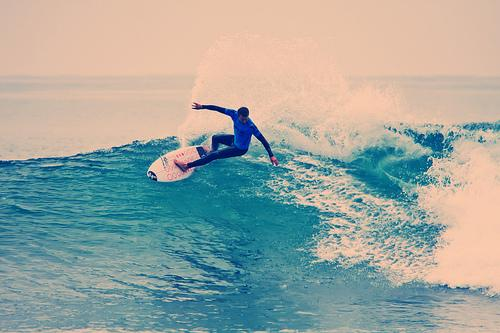Describe the overall atmosphere of the image based on the weather and water conditions. The atmosphere is exhilarating and dynamic, with cloudy grey skies over the ocean and a mixture of calm blue waters and white ocean foam, spray, and cresting waves. What could be inferred about the man's skill level in surfing based on the details provided in the image? The man seems to be skilled and confident in surfing, as he is riding a cresting wave and maintaining balance with his arms extended. Analyze the composition of the image, including the placement of objects, colors, and movement. The image composition includes the man on the surfboard as the central object, surrounded by various water conditions and weather elements. There is a balance between calm and dynamic elements, with the man's movement complemented by the colors of his clothing and the contrasting colors of the water and sky. What are the prominent colors of the man's clothing, and where do they appear? The prominent colors of the man's clothing are blue on his shirt, black on the pants and lettering of the shirt, and black and blue on his wetsuit. What is the main object in the image, and what are the most prominent features of its environment? The main object is a man on a surfboard. Features of the environment include white ocean foam, a cresting wave, calm blue waters, cloudy grey skies, and ocean spray. List all visible elements of the man's appearance that allow you to infer he is a surfer. Surfboard, wetsuit, extended arms for balancing, position on a wave, and the presence of ocean spray and white surf. Count the number of surfboard-related objects or details mentioned in the image. There are at least 7 surfboard-related objects or details: the surfboard itself, red lettering, white color, edge of the board, part of the board, pink rings, and the man on the surfboard. Describe any water-related objects or details surrounding the man in the image. There is white ocean foam in front of a wave, ocean spray coming off the back of the surfboard, a cresting wave rolling over, calm blue water behind the wave, white surf next to the man, and crystal blue water in front of him. Identify two different actions that the man on the surfboard is performing. The man is riding the surfboard and kicking up white spray with the surfboard. Mention two colors and their corresponding objects found in the image. Blue can be seen on the man's wetsuit, and red on the lettering on the white surfboard. Can you see any branding or logo on surfboard and man's shirt? Yes, there is red lettering on the surfboard and black lettering on the man's shirt Combine the following elements in a descriptive sentence: cloud, wetsuit, ocean, and lettering on the surfboard. As the man in the blue wetsuit gracefully glides amidst a cloudy ocean landscape, his white surfboard boasts vibrant red and black lettering that catches the eye. Choose the correct statement: The man is riding the wave toward the shore or The man is diving into the waves? The man is riding the wave toward the shore. What is the man's position in relation to the cresting wave? The man is in front of the cresting wave. Identify any text that appears on the surfing equipment or clothing. Red and black lettering on the surfboard, black lettering on the man's shirt Create a brief text and image-based tutorial for surfing, demonstrating correct arm position and balance while mentioning the importance of a good wetsuit. Text: Master the art of surfing with these simple tips: Maintain your balance while you keep your arms extended as our inspiring surfer in the blue wetsuit shows. Speaking of wetsuits, invest in a flexible one to keep yourself warm and agile in the water! Based on the given objects, do the captions support the idea that the surfer is performing an impressive maneuver on a beautiful day? Yes, the captions describe the scene with favorable and positive elements. Which of the following describes the ocean water behind the wave: stormy, calm, or rough? calm Recount the depicted scene using a combination of a poetic style and factual language. Amidst the serene canvas of grey skies, a courageous man conquers a swelling wave on his trusted white surfboard. The blue wetsuit clings to his form as he kicks up ocean spray, a majestic display of poetry in motion. Identify the colors of the sky, the wetsuit, and the lettering on the surfboard, respectively. Grey, blue, and red Which word describes the water surface around the man's surfboard: clear or foamy? Foamy Is the surfer's posture appropriate for the activity? Yes, the surfer's posture is appropriate. What three colors dominate the scene? Blue, white, and grey What event is taking place in the scene? A man is catching a wave on a surfboard. What activity is the man engaged in? Surfing 